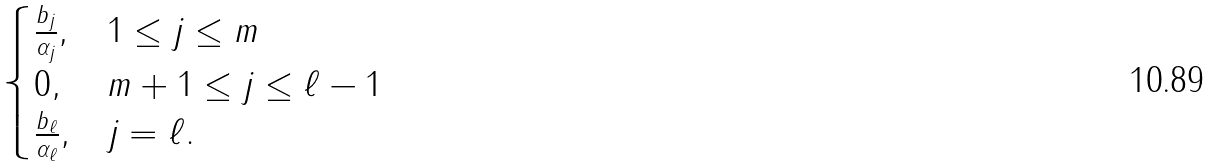<formula> <loc_0><loc_0><loc_500><loc_500>\begin{cases} \frac { b _ { j } } { \alpha _ { j } } , & 1 \leq j \leq m \\ 0 , & m + 1 \leq j \leq \ell - 1 \\ \frac { b _ { \ell } } { \alpha _ { \ell } } , & j = \ell . \end{cases}</formula> 